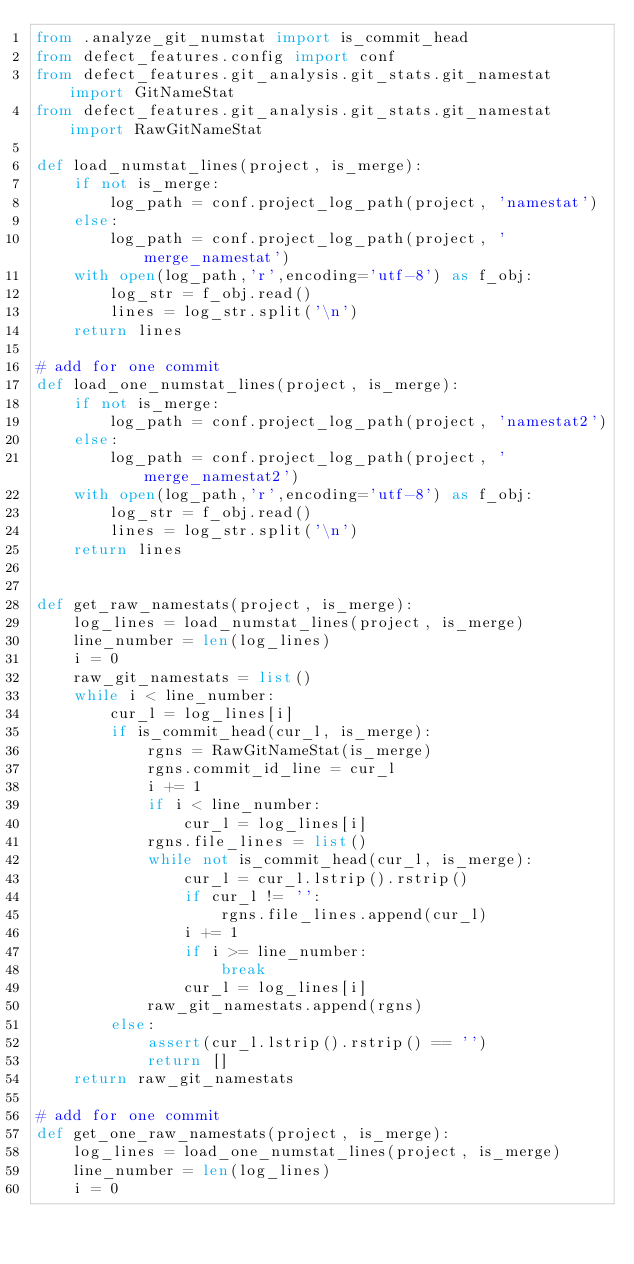<code> <loc_0><loc_0><loc_500><loc_500><_Python_>from .analyze_git_numstat import is_commit_head
from defect_features.config import conf
from defect_features.git_analysis.git_stats.git_namestat import GitNameStat
from defect_features.git_analysis.git_stats.git_namestat import RawGitNameStat

def load_numstat_lines(project, is_merge):
    if not is_merge:
        log_path = conf.project_log_path(project, 'namestat')
    else:
        log_path = conf.project_log_path(project, 'merge_namestat')
    with open(log_path,'r',encoding='utf-8') as f_obj:
        log_str = f_obj.read()
        lines = log_str.split('\n')
    return lines

# add for one commit
def load_one_numstat_lines(project, is_merge):
    if not is_merge:
        log_path = conf.project_log_path(project, 'namestat2')
    else:
        log_path = conf.project_log_path(project, 'merge_namestat2')
    with open(log_path,'r',encoding='utf-8') as f_obj:
        log_str = f_obj.read()
        lines = log_str.split('\n')
    return lines


def get_raw_namestats(project, is_merge):
    log_lines = load_numstat_lines(project, is_merge)
    line_number = len(log_lines)
    i = 0
    raw_git_namestats = list()
    while i < line_number:
        cur_l = log_lines[i]
        if is_commit_head(cur_l, is_merge):
            rgns = RawGitNameStat(is_merge)
            rgns.commit_id_line = cur_l
            i += 1
            if i < line_number:
                cur_l = log_lines[i]
            rgns.file_lines = list()
            while not is_commit_head(cur_l, is_merge):
                cur_l = cur_l.lstrip().rstrip()
                if cur_l != '':
                    rgns.file_lines.append(cur_l)
                i += 1
                if i >= line_number:
                    break
                cur_l = log_lines[i]
            raw_git_namestats.append(rgns)
        else:
            assert(cur_l.lstrip().rstrip() == '')
            return []
    return raw_git_namestats

# add for one commit
def get_one_raw_namestats(project, is_merge):
    log_lines = load_one_numstat_lines(project, is_merge)
    line_number = len(log_lines)
    i = 0</code> 